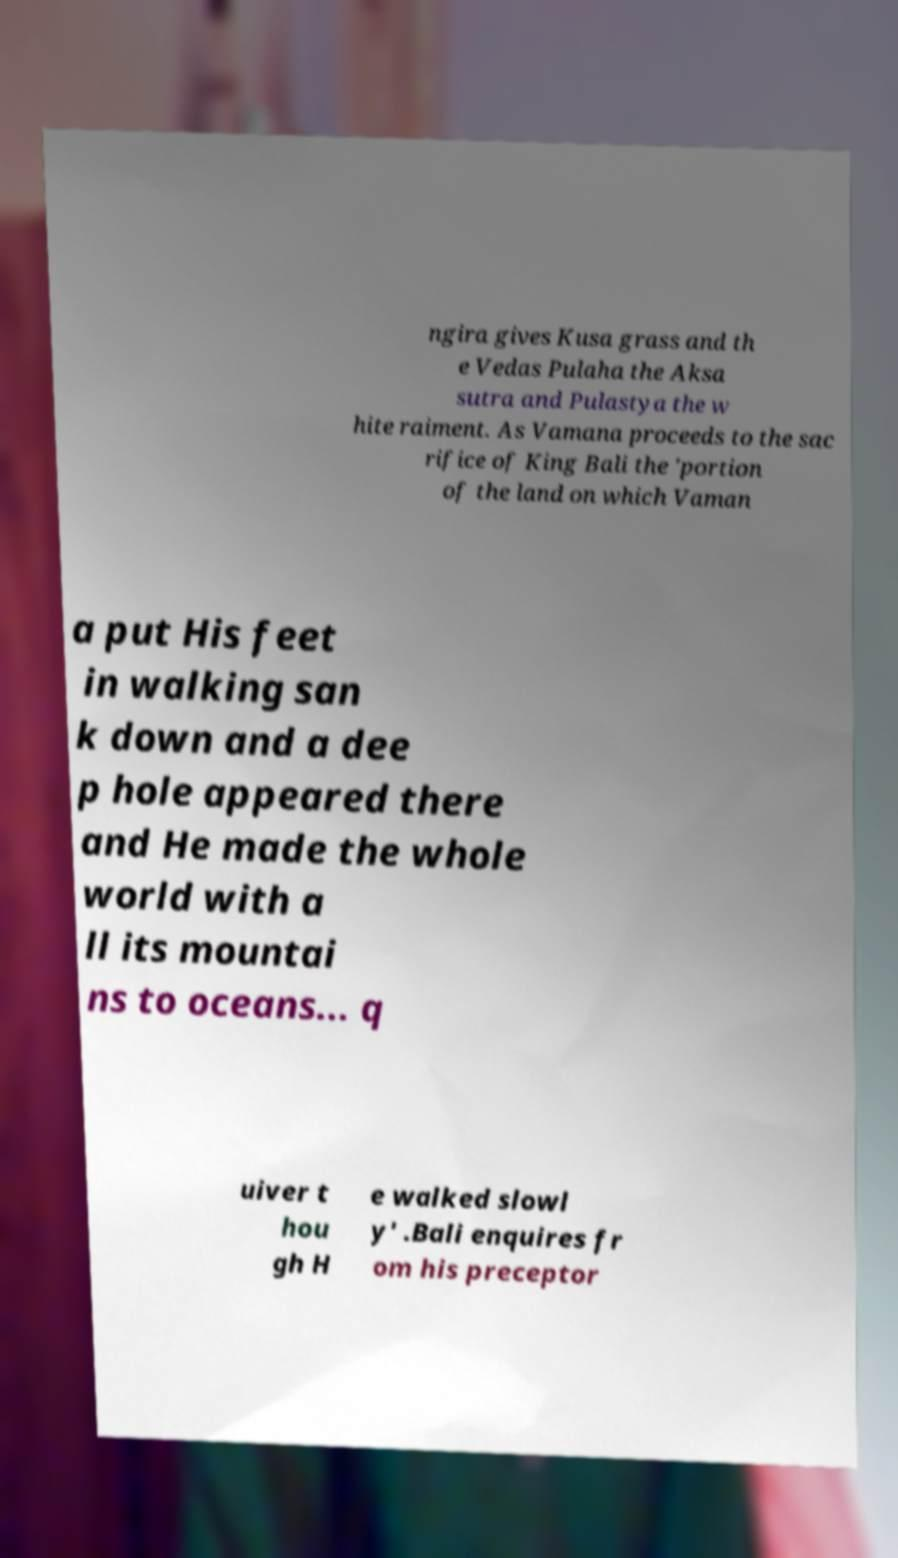Could you assist in decoding the text presented in this image and type it out clearly? ngira gives Kusa grass and th e Vedas Pulaha the Aksa sutra and Pulastya the w hite raiment. As Vamana proceeds to the sac rifice of King Bali the 'portion of the land on which Vaman a put His feet in walking san k down and a dee p hole appeared there and He made the whole world with a ll its mountai ns to oceans... q uiver t hou gh H e walked slowl y' .Bali enquires fr om his preceptor 